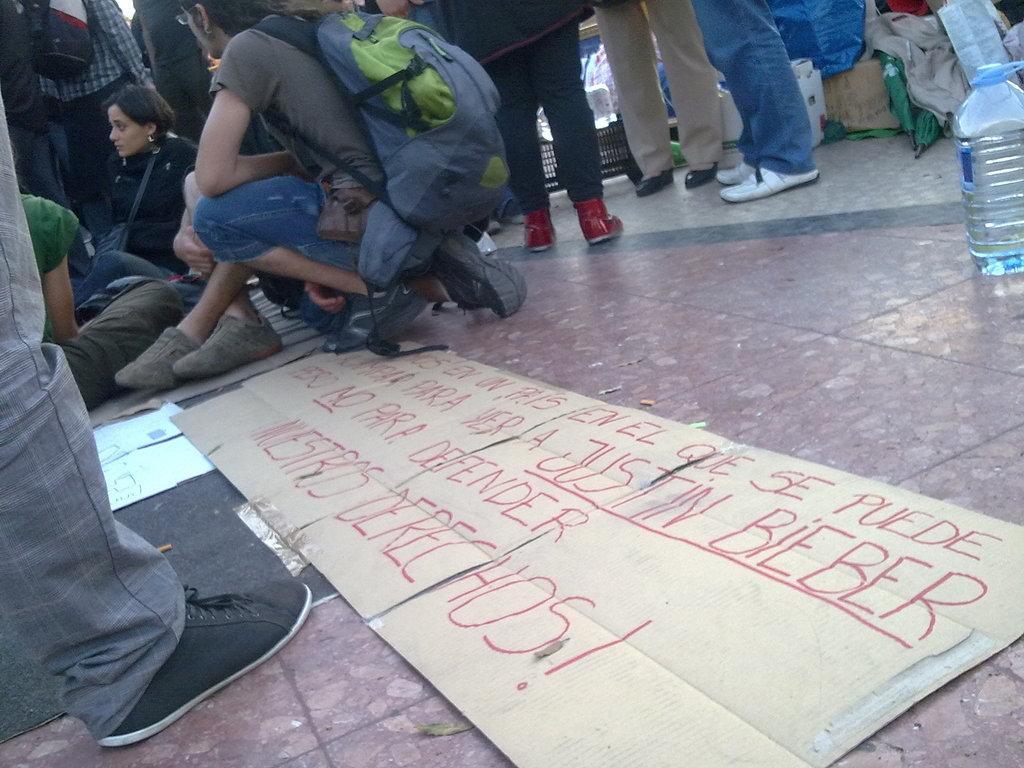Please provide a concise description of this image. In this image I can see few people are sitting on the floor and few people are standing. On the right side of the image there is a bottle. On the floor there is a sheet. On the top right corner of the image there are some clothes 